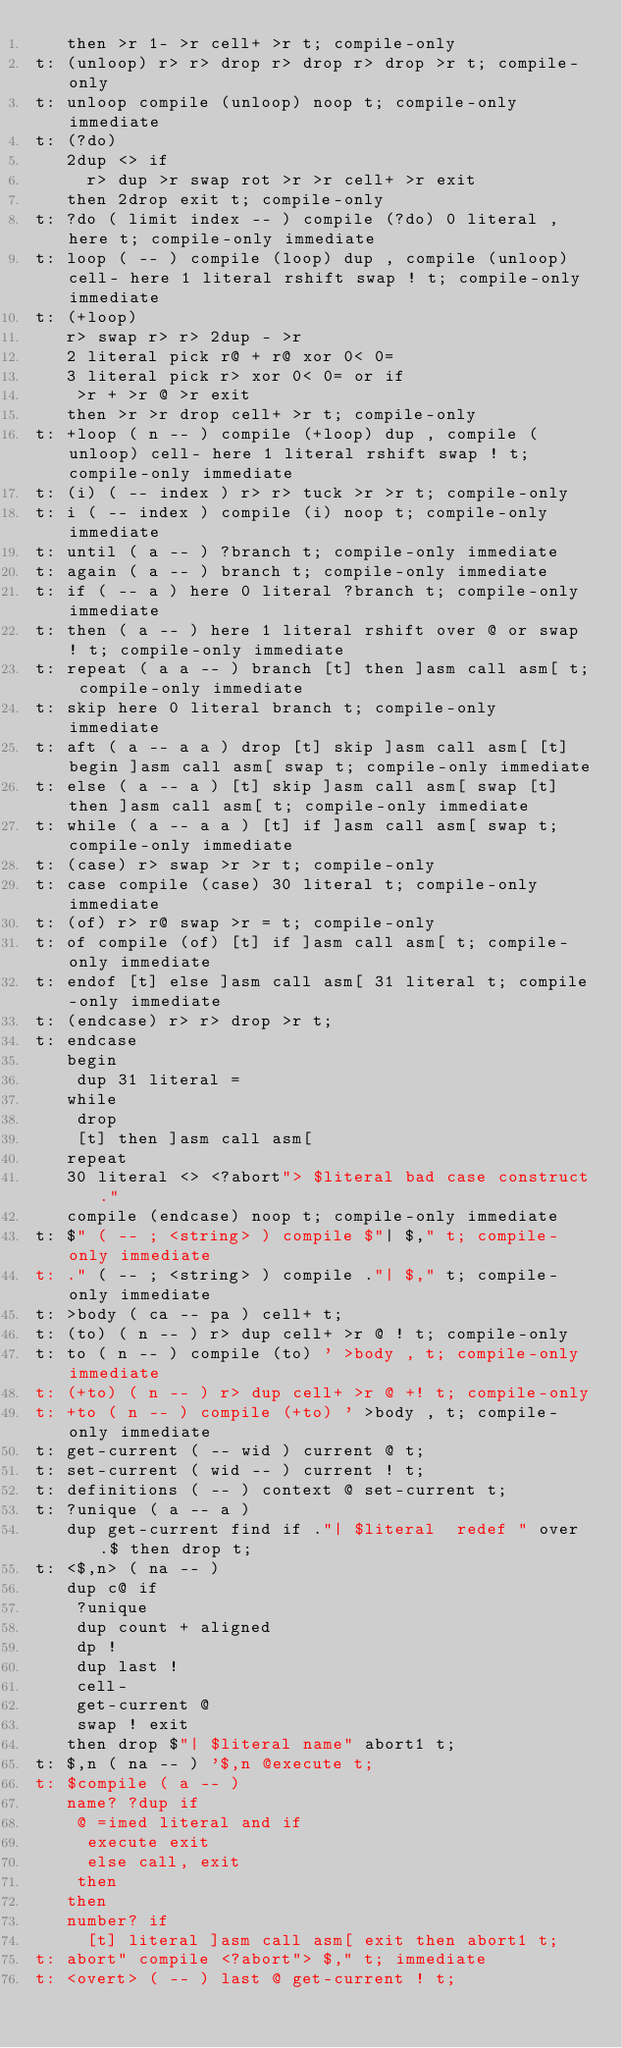Convert code to text. <code><loc_0><loc_0><loc_500><loc_500><_Forth_>   then >r 1- >r cell+ >r t; compile-only
t: (unloop) r> r> drop r> drop r> drop >r t; compile-only
t: unloop compile (unloop) noop t; compile-only immediate
t: (?do)
   2dup <> if
     r> dup >r swap rot >r >r cell+ >r exit
   then 2drop exit t; compile-only
t: ?do ( limit index -- ) compile (?do) 0 literal , here t; compile-only immediate
t: loop ( -- ) compile (loop) dup , compile (unloop) cell- here 1 literal rshift swap ! t; compile-only immediate
t: (+loop)
   r> swap r> r> 2dup - >r
   2 literal pick r@ + r@ xor 0< 0=
   3 literal pick r> xor 0< 0= or if
    >r + >r @ >r exit
   then >r >r drop cell+ >r t; compile-only
t: +loop ( n -- ) compile (+loop) dup , compile (unloop) cell- here 1 literal rshift swap ! t; compile-only immediate
t: (i) ( -- index ) r> r> tuck >r >r t; compile-only
t: i ( -- index ) compile (i) noop t; compile-only immediate
t: until ( a -- ) ?branch t; compile-only immediate
t: again ( a -- ) branch t; compile-only immediate
t: if ( -- a ) here 0 literal ?branch t; compile-only immediate
t: then ( a -- ) here 1 literal rshift over @ or swap ! t; compile-only immediate
t: repeat ( a a -- ) branch [t] then ]asm call asm[ t; compile-only immediate
t: skip here 0 literal branch t; compile-only immediate
t: aft ( a -- a a ) drop [t] skip ]asm call asm[ [t] begin ]asm call asm[ swap t; compile-only immediate
t: else ( a -- a ) [t] skip ]asm call asm[ swap [t] then ]asm call asm[ t; compile-only immediate
t: while ( a -- a a ) [t] if ]asm call asm[ swap t; compile-only immediate
t: (case) r> swap >r >r	t; compile-only
t: case compile (case) 30 literal t; compile-only immediate
t: (of) r> r@ swap >r = t; compile-only
t: of compile (of) [t] if ]asm call asm[ t; compile-only immediate
t: endof [t] else ]asm call asm[ 31 literal t; compile-only immediate
t: (endcase) r> r> drop >r t;
t: endcase
   begin
    dup 31 literal =
   while
    drop			
    [t] then ]asm call asm[
   repeat
   30 literal <> <?abort"> $literal bad case construct."
   compile (endcase) noop t; compile-only immediate
t: $" ( -- ; <string> ) compile $"| $," t; compile-only immediate
t: ." ( -- ; <string> ) compile ."| $," t; compile-only immediate
t: >body ( ca -- pa ) cell+ t;
t: (to) ( n -- ) r> dup cell+ >r @ ! t; compile-only
t: to ( n -- ) compile (to) ' >body , t; compile-only immediate
t: (+to) ( n -- ) r> dup cell+ >r @ +! t; compile-only
t: +to ( n -- ) compile (+to) ' >body , t; compile-only immediate
t: get-current ( -- wid ) current @ t;
t: set-current ( wid -- ) current ! t;
t: definitions ( -- ) context @ set-current t;
t: ?unique ( a -- a )
   dup get-current find if ."| $literal  redef " over .$ then drop t;
t: <$,n> ( na -- )
   dup c@ if
    ?unique
	dup count + aligned
	dp !
    dup last !
    cell-
    get-current @
    swap ! exit
   then drop $"| $literal name" abort1 t;
t: $,n ( na -- ) '$,n @execute t;
t: $compile ( a -- )
   name? ?dup if
    @ =imed literal and if
	 execute exit
	 else call, exit
	then
   then
   number? if
     [t] literal ]asm call asm[ exit then abort1 t;
t: abort" compile <?abort"> $," t; immediate
t: <overt> ( -- ) last @ get-current ! t;</code> 